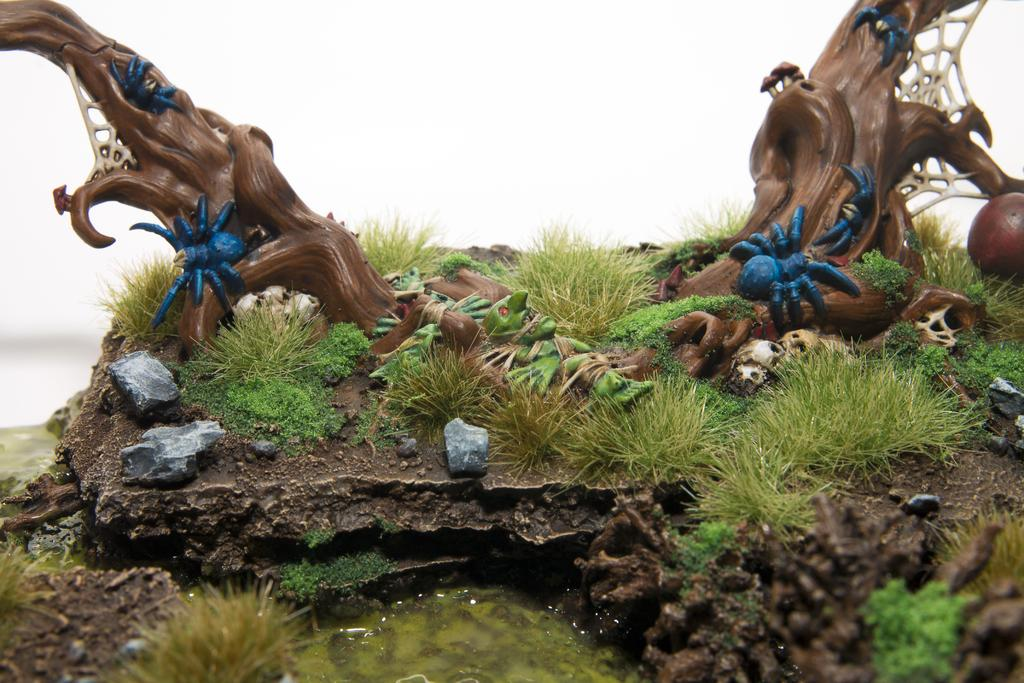What type of sculptures can be seen in the image? There are sculptures of tree branches and insects in the image. What type of natural environment is visible in the image? There is grass and water visible in the image. What other objects can be seen in the image? There are stones in the image. What is the color of the background in the image? The background of the image is white. What type of skirt is being worn by the insect in the image? There are no insects wearing skirts in the image, as the sculptures are of insects and not living insects. 